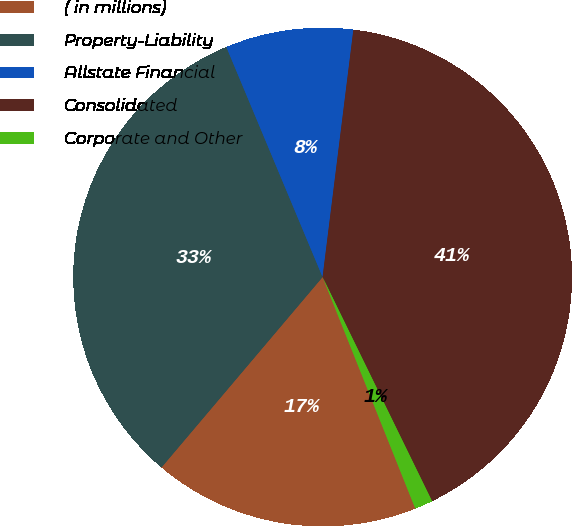Convert chart to OTSL. <chart><loc_0><loc_0><loc_500><loc_500><pie_chart><fcel>( in millions)<fcel>Property-Liability<fcel>Allstate Financial<fcel>Consolidated<fcel>Corporate and Other<nl><fcel>17.24%<fcel>32.52%<fcel>8.28%<fcel>40.8%<fcel>1.17%<nl></chart> 